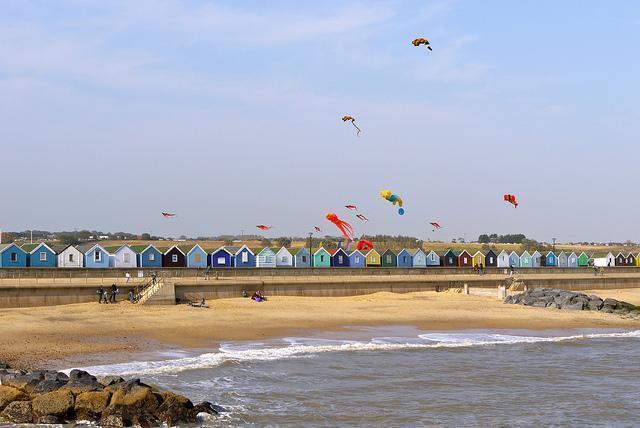Why do you need to frequently repair beach houses?
Answer the question by selecting the correct answer among the 4 following choices.
Options: Law, nosy neighbors, environmental wear, beauty. Environmental wear. 